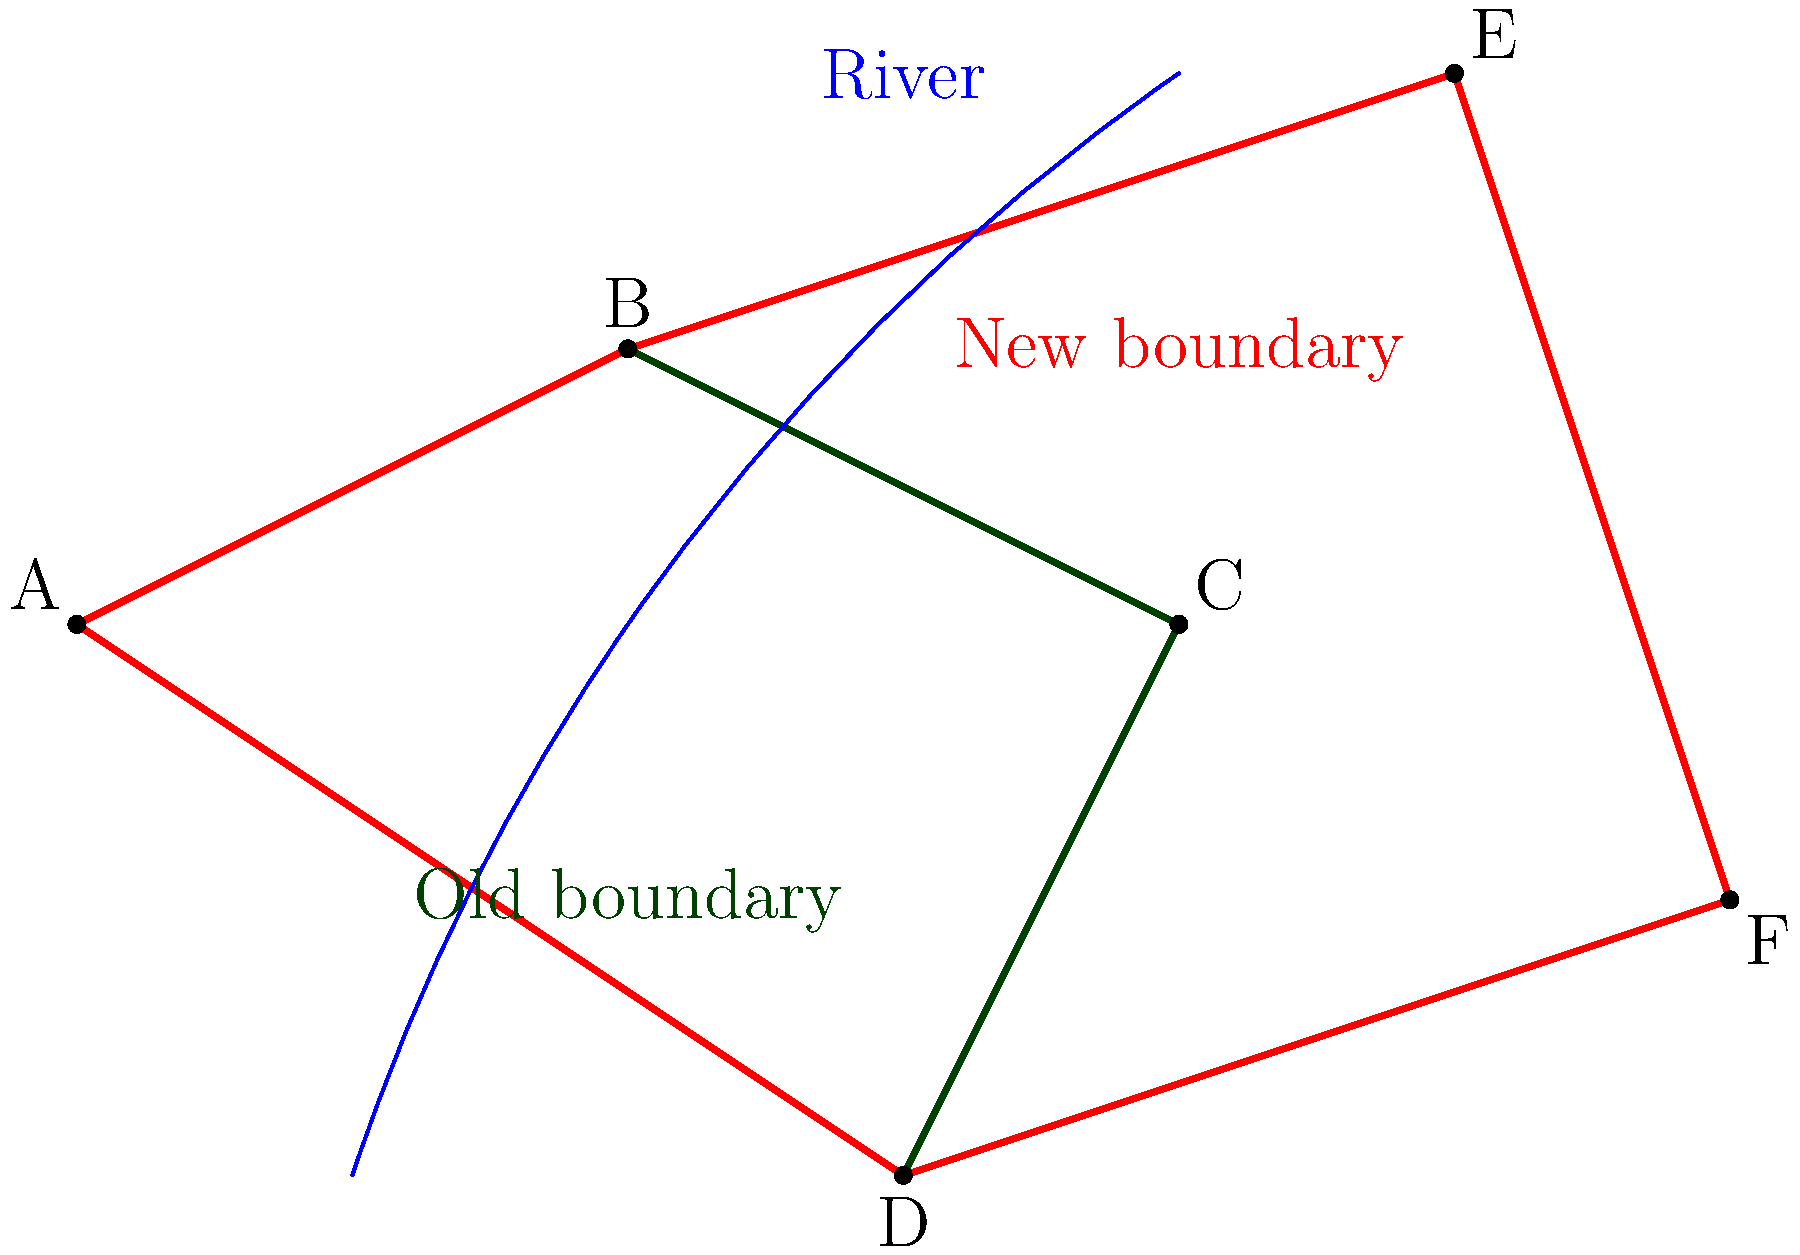Analyze the historical map showing the changing boundaries of a local town. The old boundary is marked in green, and the new boundary is marked in red. A river runs through the town, shown in blue. How has the town's area changed, and what geographical feature might have influenced this expansion? To analyze the change in the town's area and identify the geographical influence, let's follow these steps:

1. Observe the old boundary (green):
   The old town boundary forms a quadrilateral shape ABCD.

2. Observe the new boundary (red):
   The new town boundary forms a larger polygon ABEFCD.

3. Compare the two boundaries:
   The new boundary extends beyond the old one to the east and northeast, incorporating more land.

4. Calculate the approximate change in area:
   The area has increased by roughly 30-40% based on visual estimation.

5. Identify the geographical feature:
   A river (blue line) runs through the town from southwest to northeast.

6. Analyze the relationship between the river and expansion:
   The town has expanded primarily along the eastern bank of the river.

7. Draw a conclusion:
   The river likely influenced the town's expansion by providing water resources and potentially fertile land along its banks, making it attractive for settlement and development.
Answer: The town's area increased by ~30-40%, expanding eastward along the river, which likely influenced its growth due to water access and fertile land. 